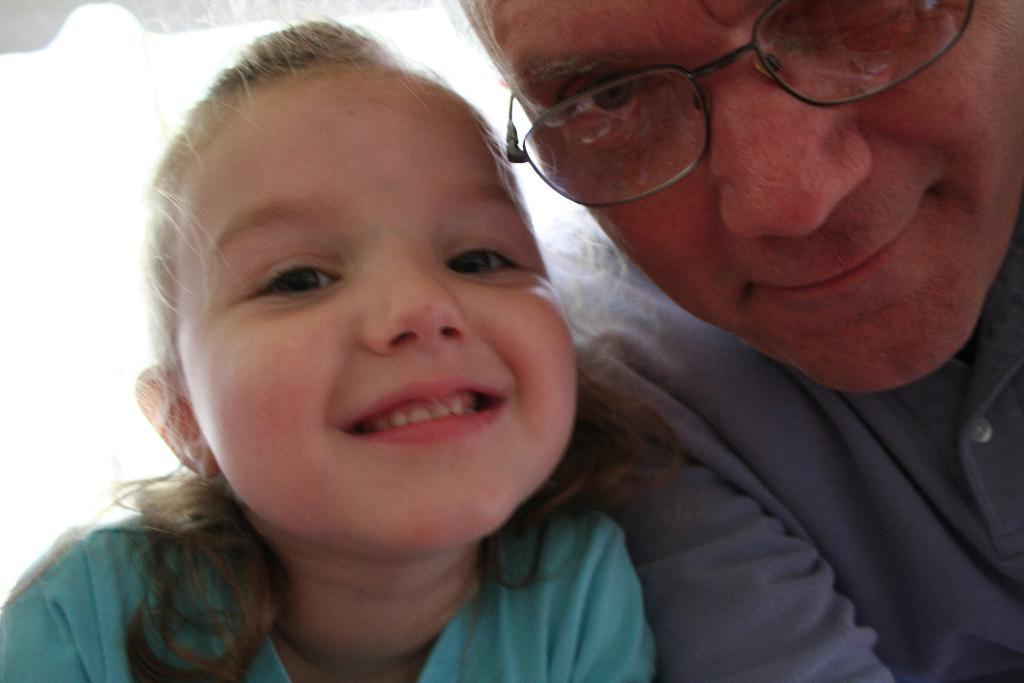Who are the people in the image? There is a man and a girl in the image. What expressions do the people in the image have? The man and the girl are both smiling. What type of yarn is the maid using to clean the floor in the image? There is no maid or yarn present in the image. What kind of pain is the girl experiencing in the image? There is no indication of pain or any discomfort in the image. 